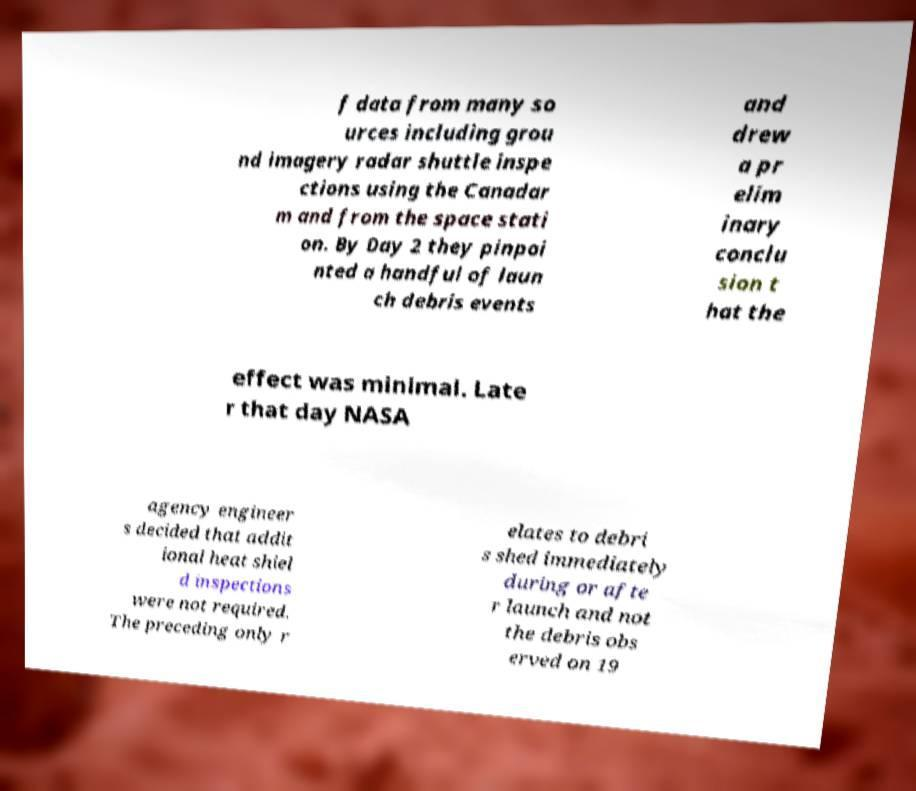There's text embedded in this image that I need extracted. Can you transcribe it verbatim? f data from many so urces including grou nd imagery radar shuttle inspe ctions using the Canadar m and from the space stati on. By Day 2 they pinpoi nted a handful of laun ch debris events and drew a pr elim inary conclu sion t hat the effect was minimal. Late r that day NASA agency engineer s decided that addit ional heat shiel d inspections were not required. The preceding only r elates to debri s shed immediately during or afte r launch and not the debris obs erved on 19 